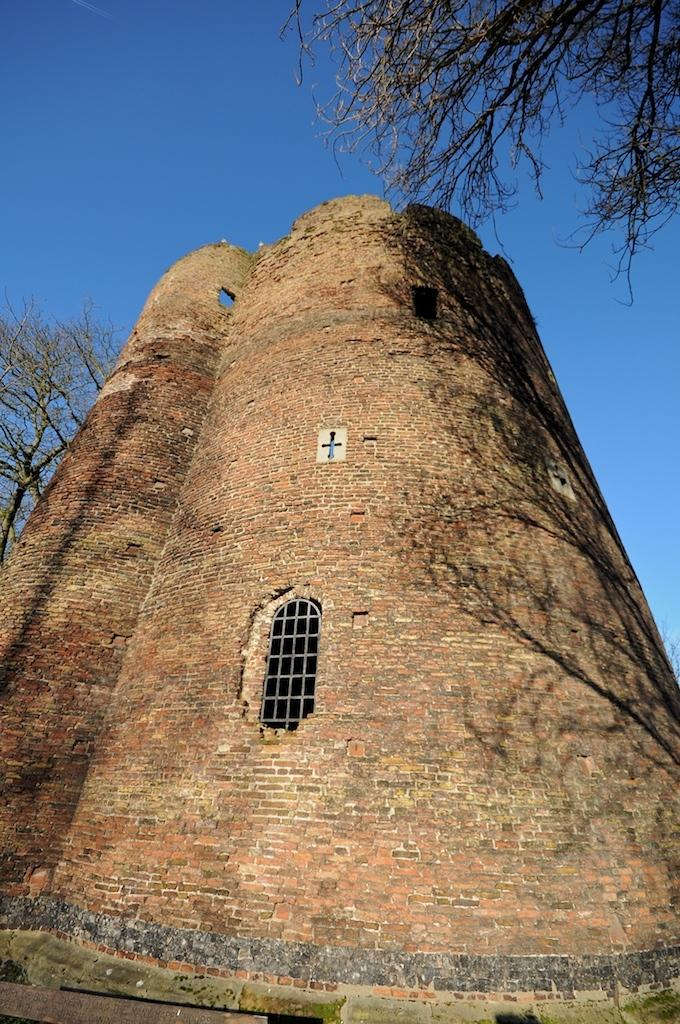What type of structure is present in the image? There is a building in the image. What other natural elements can be seen in the image? There are trees in the image. What part of the environment is visible in the image? The sky is visible in the image. What type of current can be seen flowing through the building in the image? There is no current visible in the image; it is a still image of a building with trees and the sky. 